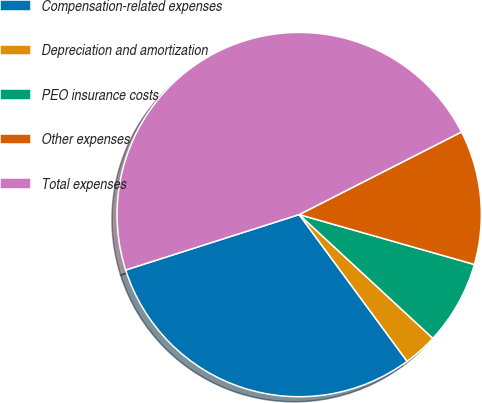Convert chart. <chart><loc_0><loc_0><loc_500><loc_500><pie_chart><fcel>Compensation-related expenses<fcel>Depreciation and amortization<fcel>PEO insurance costs<fcel>Other expenses<fcel>Total expenses<nl><fcel>30.17%<fcel>3.02%<fcel>7.47%<fcel>11.91%<fcel>47.43%<nl></chart> 